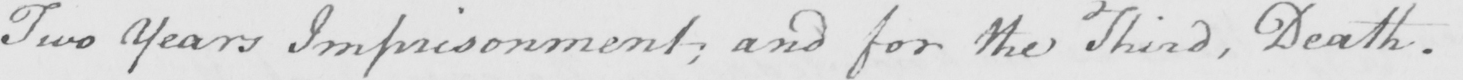What is written in this line of handwriting? Two Years Imprisonment ; and for the Third , Death . 